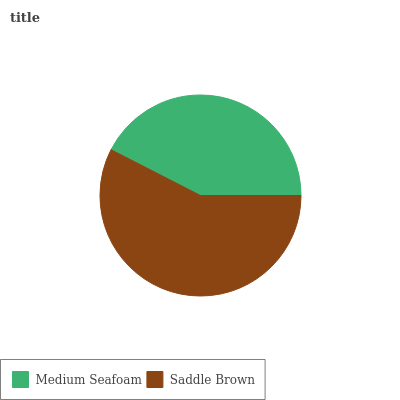Is Medium Seafoam the minimum?
Answer yes or no. Yes. Is Saddle Brown the maximum?
Answer yes or no. Yes. Is Saddle Brown the minimum?
Answer yes or no. No. Is Saddle Brown greater than Medium Seafoam?
Answer yes or no. Yes. Is Medium Seafoam less than Saddle Brown?
Answer yes or no. Yes. Is Medium Seafoam greater than Saddle Brown?
Answer yes or no. No. Is Saddle Brown less than Medium Seafoam?
Answer yes or no. No. Is Saddle Brown the high median?
Answer yes or no. Yes. Is Medium Seafoam the low median?
Answer yes or no. Yes. Is Medium Seafoam the high median?
Answer yes or no. No. Is Saddle Brown the low median?
Answer yes or no. No. 